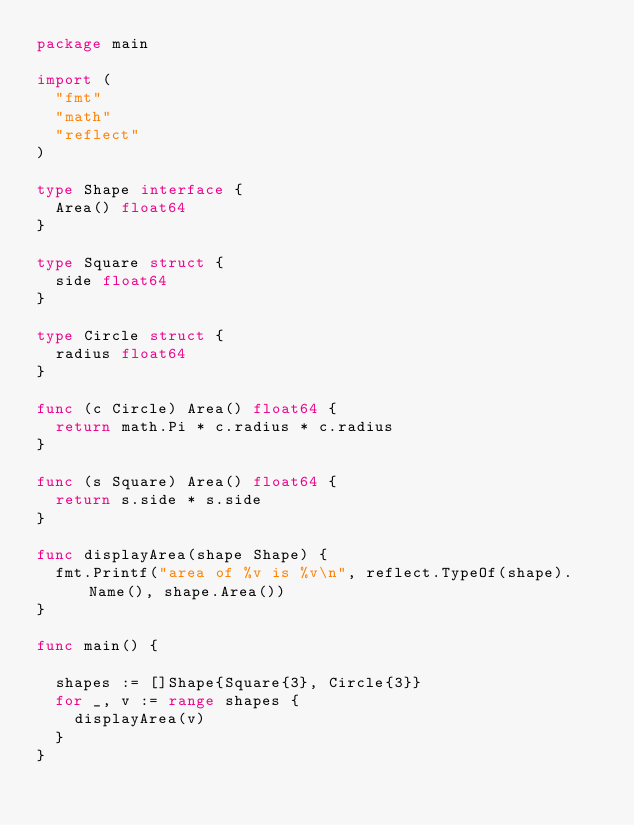Convert code to text. <code><loc_0><loc_0><loc_500><loc_500><_Go_>package main

import (
	"fmt"
	"math"
	"reflect"
)

type Shape interface {
	Area() float64
}

type Square struct {
	side float64
}

type Circle struct {
	radius float64
}

func (c Circle) Area() float64 {
	return math.Pi * c.radius * c.radius
}

func (s Square) Area() float64 {
	return s.side * s.side
}

func displayArea(shape Shape) {
	fmt.Printf("area of %v is %v\n", reflect.TypeOf(shape).Name(), shape.Area())
}

func main() {

	shapes := []Shape{Square{3}, Circle{3}}
	for _, v := range shapes {
		displayArea(v)
	}
}
</code> 